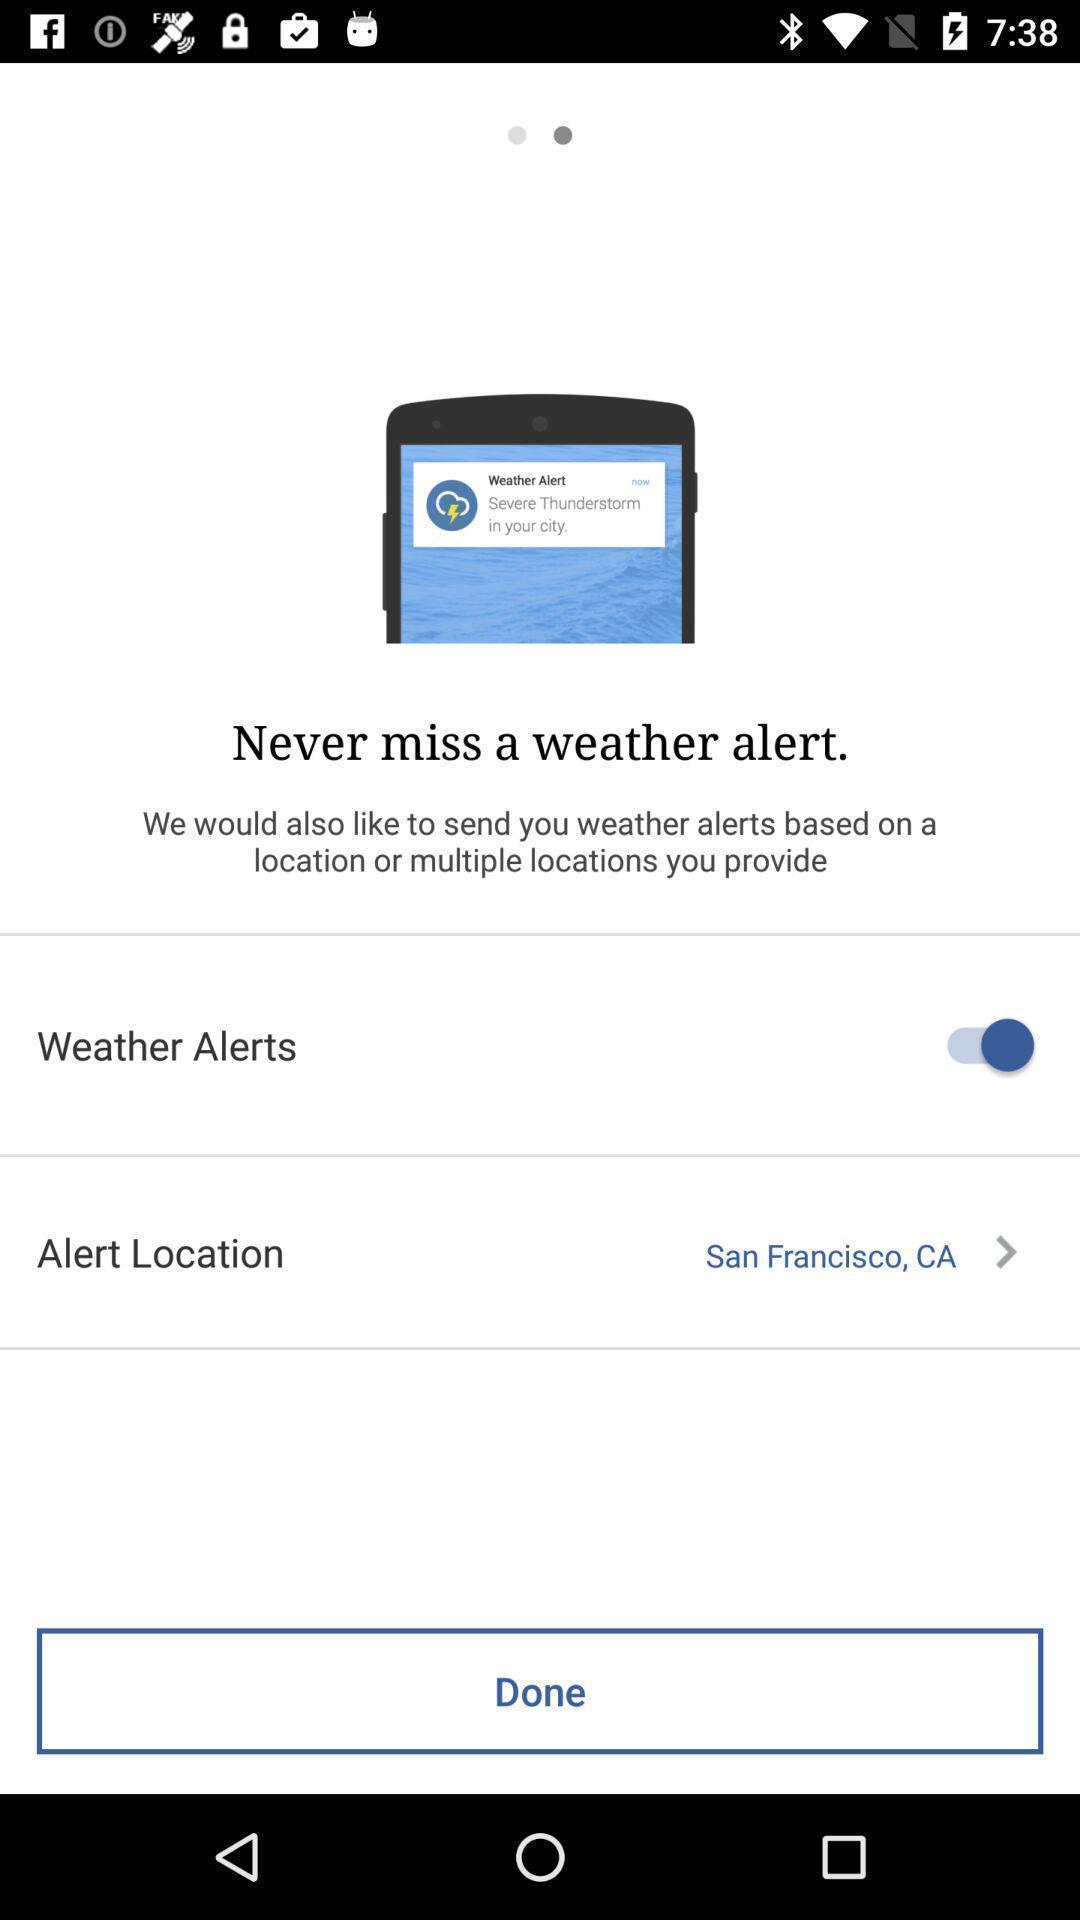Provide a textual representation of this image. Page displays to set weather alerts in app. 